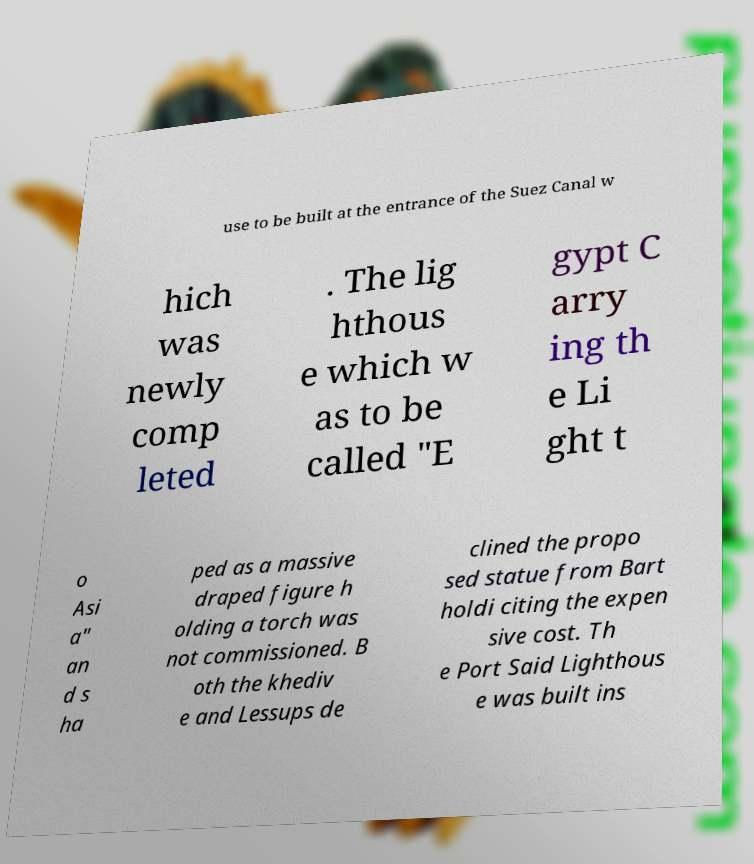Please read and relay the text visible in this image. What does it say? use to be built at the entrance of the Suez Canal w hich was newly comp leted . The lig hthous e which w as to be called "E gypt C arry ing th e Li ght t o Asi a" an d s ha ped as a massive draped figure h olding a torch was not commissioned. B oth the khediv e and Lessups de clined the propo sed statue from Bart holdi citing the expen sive cost. Th e Port Said Lighthous e was built ins 